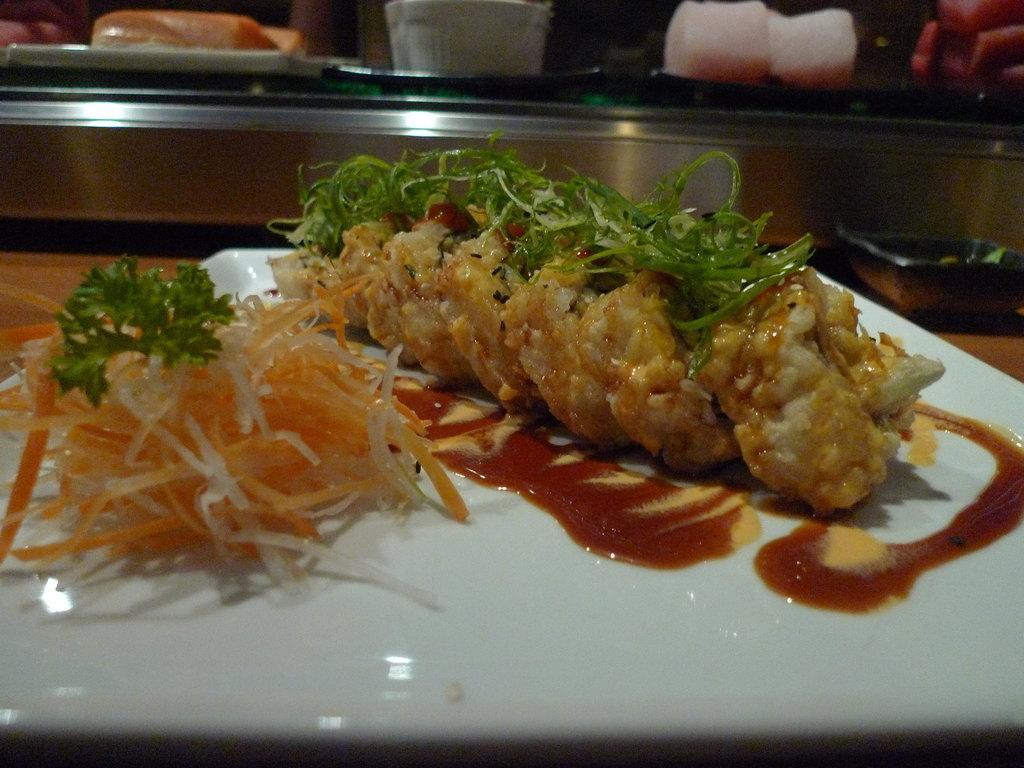Please provide a concise description of this image. In this image there is a white plate on which there is food. On the food there is tomato sauce. In the background there is an iron tray. On the food there are coriander leaves. 